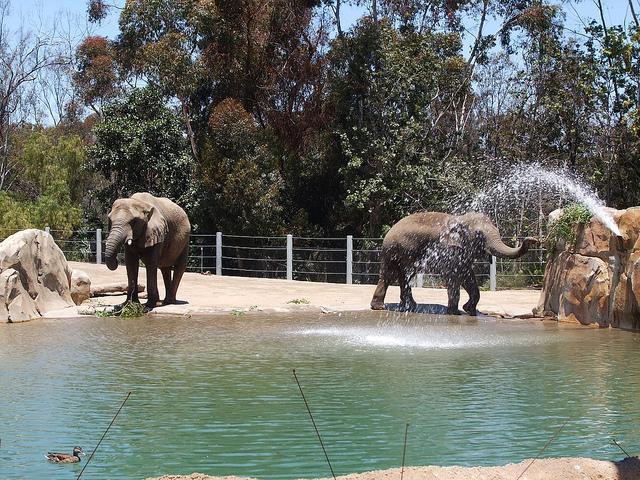How many elephants are there?
Give a very brief answer. 2. How many people are wearing helmet?
Give a very brief answer. 0. 